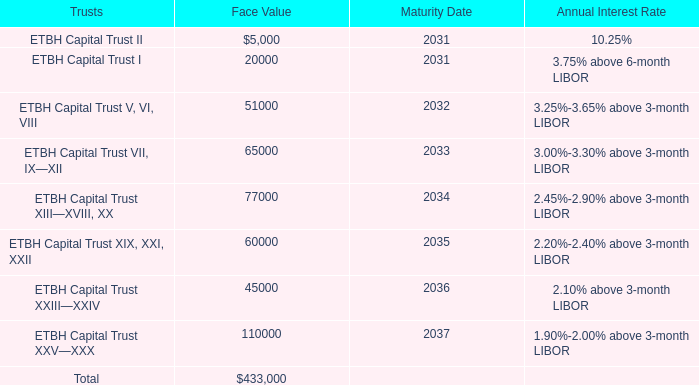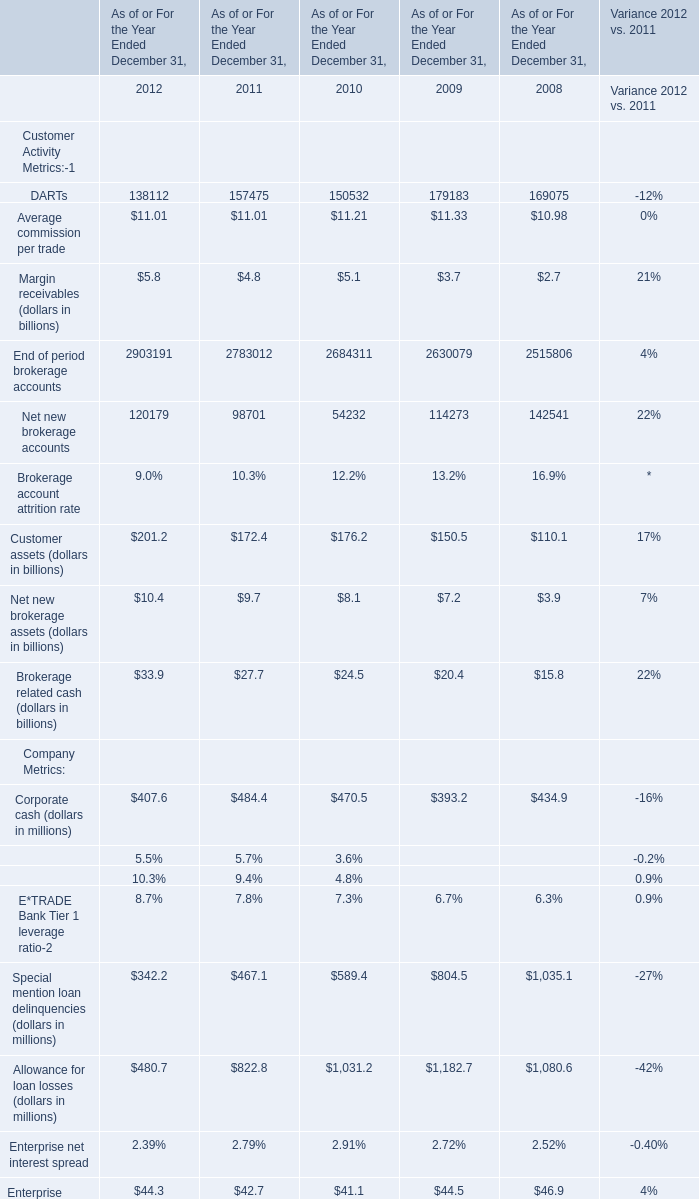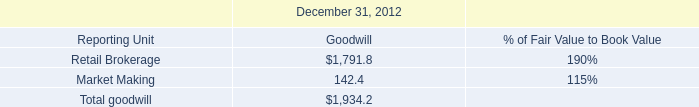Which year the Average commission per trade is the highest? 
Answer: 2009. 